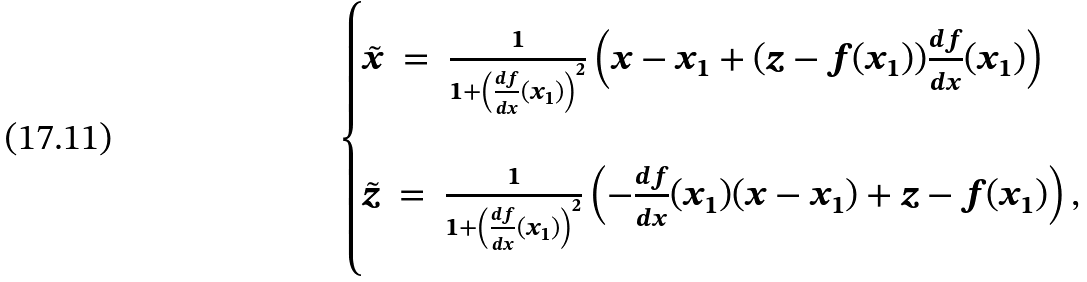Convert formula to latex. <formula><loc_0><loc_0><loc_500><loc_500>\begin{cases} \tilde { x } \ = \ \frac { 1 } { 1 + \left ( \frac { d f } { d x } ( x _ { 1 } ) \right ) ^ { 2 } } \left ( x - x _ { 1 } + ( z - f ( x _ { 1 } ) ) \frac { d f } { d x } ( x _ { 1 } ) \right ) \\ \\ \tilde { z } \ = \ \frac { 1 } { 1 + \left ( \frac { d f } { d x } ( x _ { 1 } ) \right ) ^ { 2 } } \left ( - \frac { d f } { d x } ( x _ { 1 } ) ( x - x _ { 1 } ) + z - f ( x _ { 1 } ) \right ) , \end{cases}</formula> 